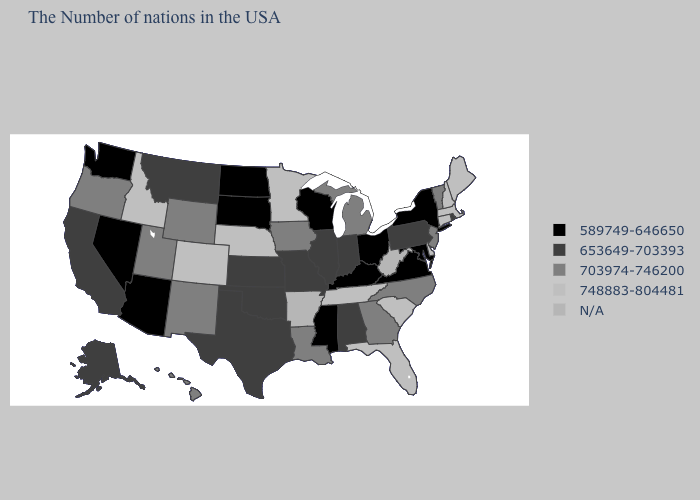What is the value of North Dakota?
Short answer required. 589749-646650. Among the states that border Texas , which have the highest value?
Be succinct. Louisiana, New Mexico. Does North Carolina have the lowest value in the USA?
Answer briefly. No. What is the value of Nevada?
Answer briefly. 589749-646650. Does Colorado have the highest value in the West?
Concise answer only. Yes. Which states have the highest value in the USA?
Write a very short answer. Maine, Massachusetts, New Hampshire, Connecticut, Delaware, South Carolina, Florida, Tennessee, Minnesota, Nebraska, Colorado, Idaho. Name the states that have a value in the range 703974-746200?
Answer briefly. Vermont, New Jersey, North Carolina, Georgia, Michigan, Louisiana, Iowa, Wyoming, New Mexico, Utah, Oregon, Hawaii. Name the states that have a value in the range 589749-646650?
Answer briefly. New York, Maryland, Virginia, Ohio, Kentucky, Wisconsin, Mississippi, South Dakota, North Dakota, Arizona, Nevada, Washington. What is the value of Georgia?
Give a very brief answer. 703974-746200. Among the states that border Montana , does North Dakota have the lowest value?
Concise answer only. Yes. Among the states that border Missouri , does Nebraska have the highest value?
Answer briefly. Yes. Does the first symbol in the legend represent the smallest category?
Short answer required. Yes. What is the value of South Dakota?
Answer briefly. 589749-646650. Among the states that border New York , does Connecticut have the highest value?
Be succinct. Yes. 